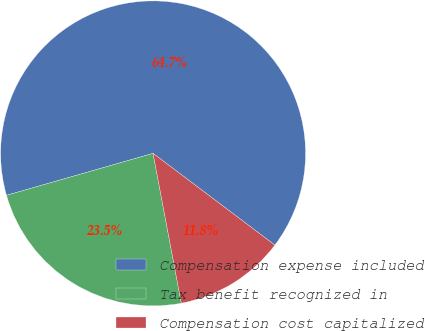Convert chart. <chart><loc_0><loc_0><loc_500><loc_500><pie_chart><fcel>Compensation expense included<fcel>Tax benefit recognized in<fcel>Compensation cost capitalized<nl><fcel>64.71%<fcel>23.53%<fcel>11.76%<nl></chart> 